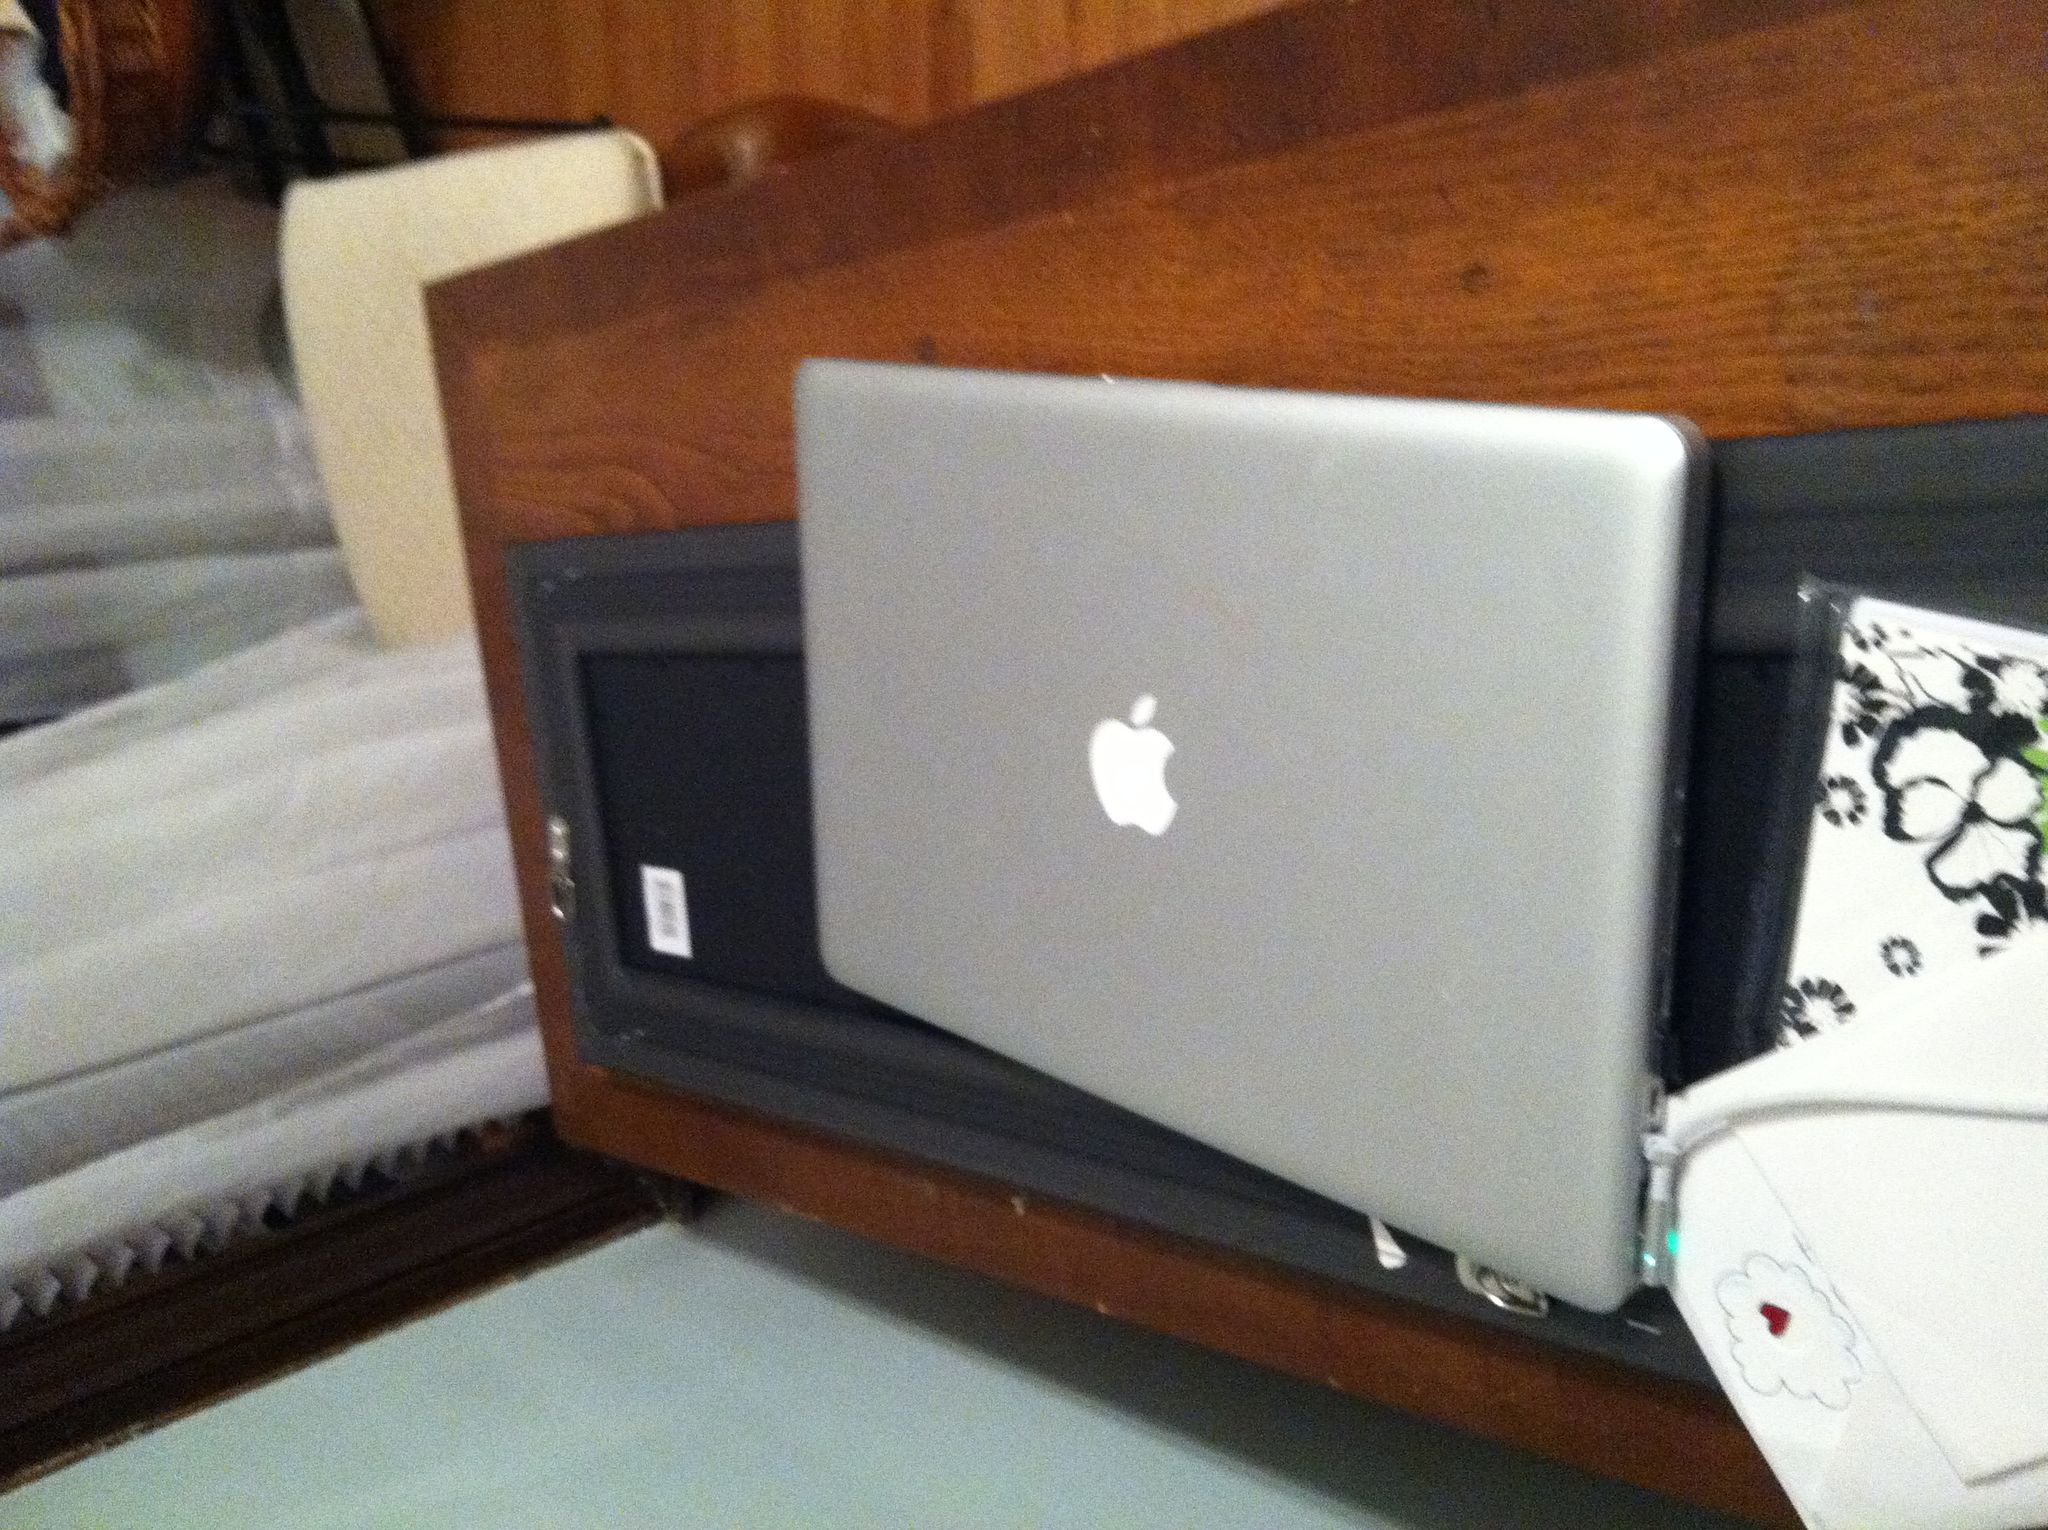What technical specifications did the iBook typically have? Typically, the iBook featured a PowerPC G3 processor, with options ranging from 300 to 900 MHz. It included a 12.1-inch TFT display and offered between 32 and 640 MB of RAM. Additionally, it had a built-in CD-ROM or DVD-ROM drive, and later models also included FireWire ports. 